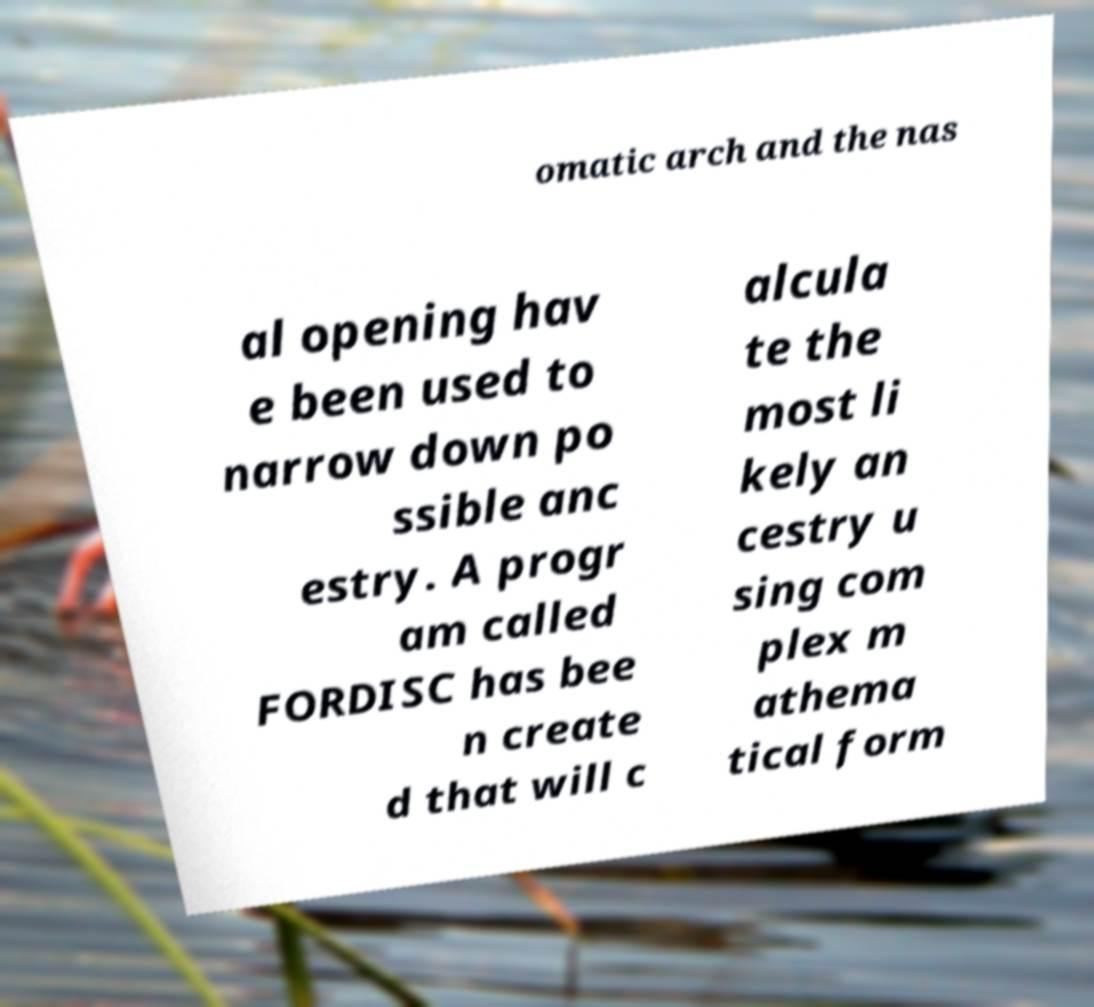Could you extract and type out the text from this image? omatic arch and the nas al opening hav e been used to narrow down po ssible anc estry. A progr am called FORDISC has bee n create d that will c alcula te the most li kely an cestry u sing com plex m athema tical form 